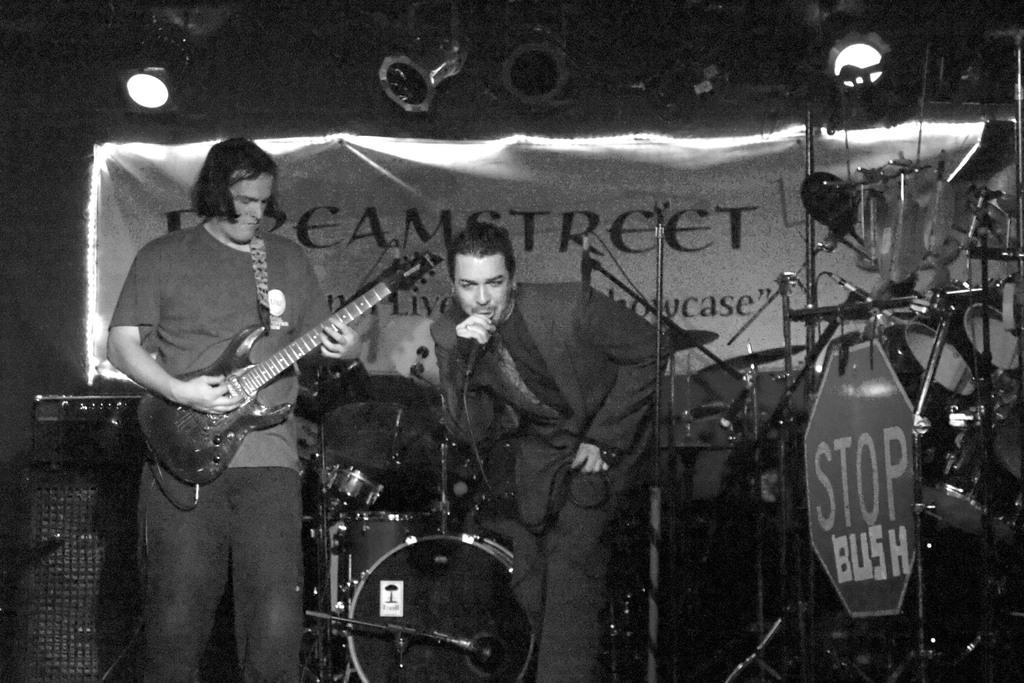What are the men in the image doing? The men in the image are standing and holding guitars. Is there a man with a different instrument in the image? Yes, there is a man holding a microphone. What can be seen in the background of the image? There are drums visible in the background. Where is the yak in the image? There is no yak present in the image. What type of nest can be seen in the image? There is no nest present in the image. 